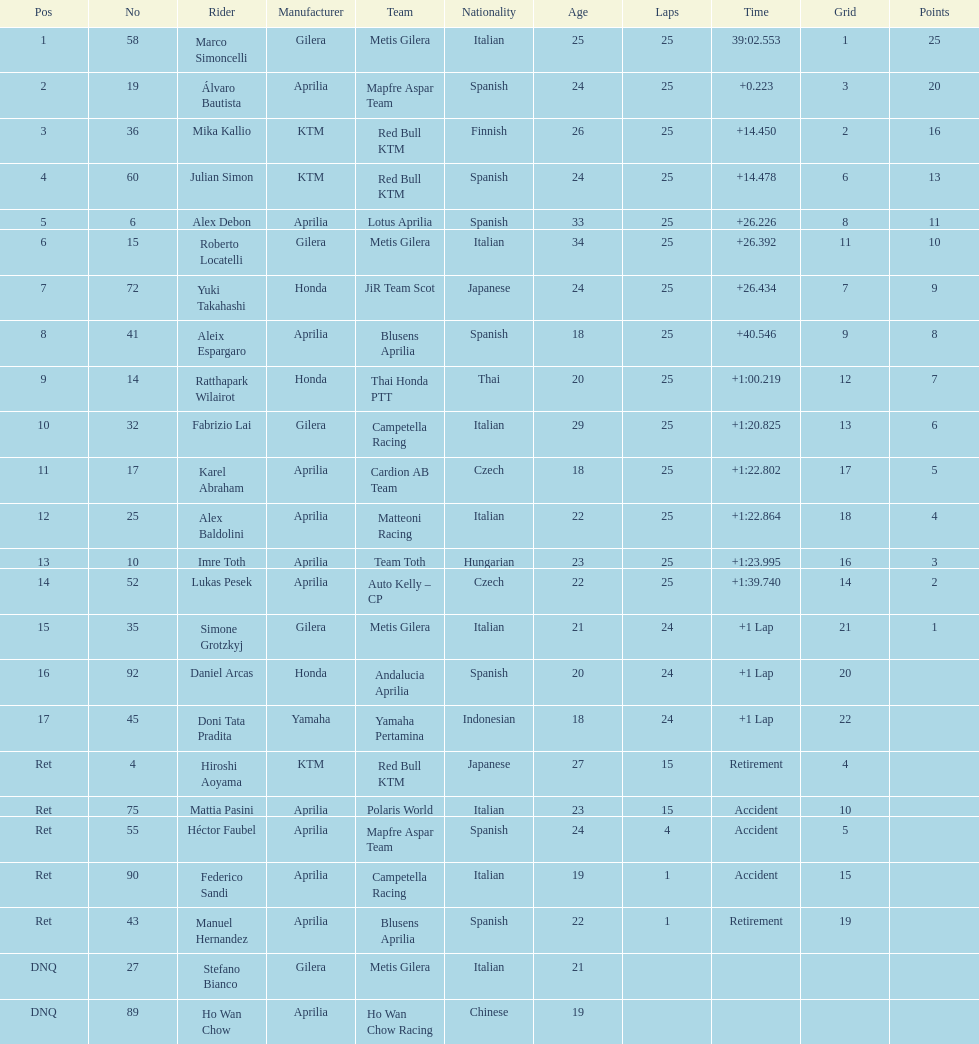What company manufactures for marco simoncelli? Gilera. 